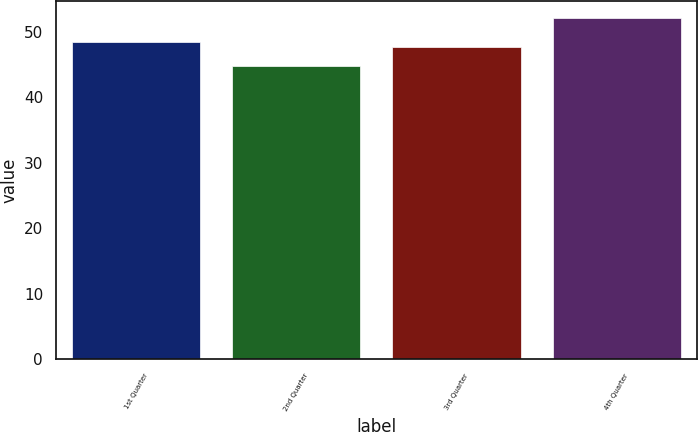Convert chart. <chart><loc_0><loc_0><loc_500><loc_500><bar_chart><fcel>1st Quarter<fcel>2nd Quarter<fcel>3rd Quarter<fcel>4th Quarter<nl><fcel>48.44<fcel>44.85<fcel>47.7<fcel>52.2<nl></chart> 